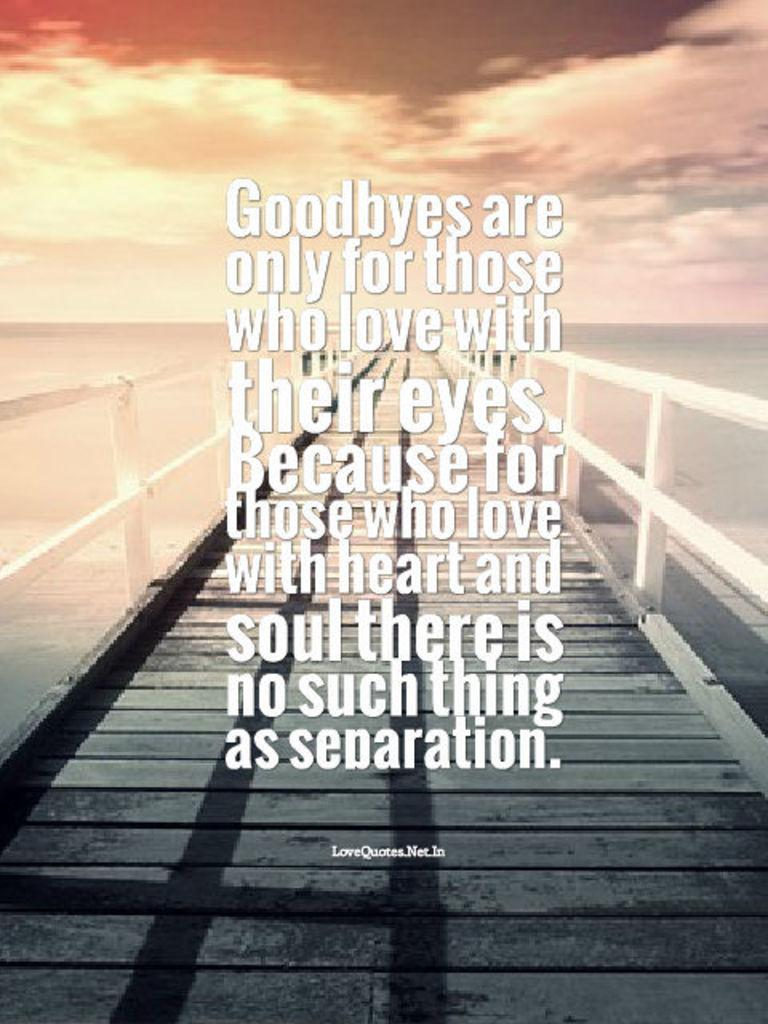<image>
Relay a brief, clear account of the picture shown. An emotional quote about goodbyes explains that there is no such thing as separation for those who love with heart and soul. 